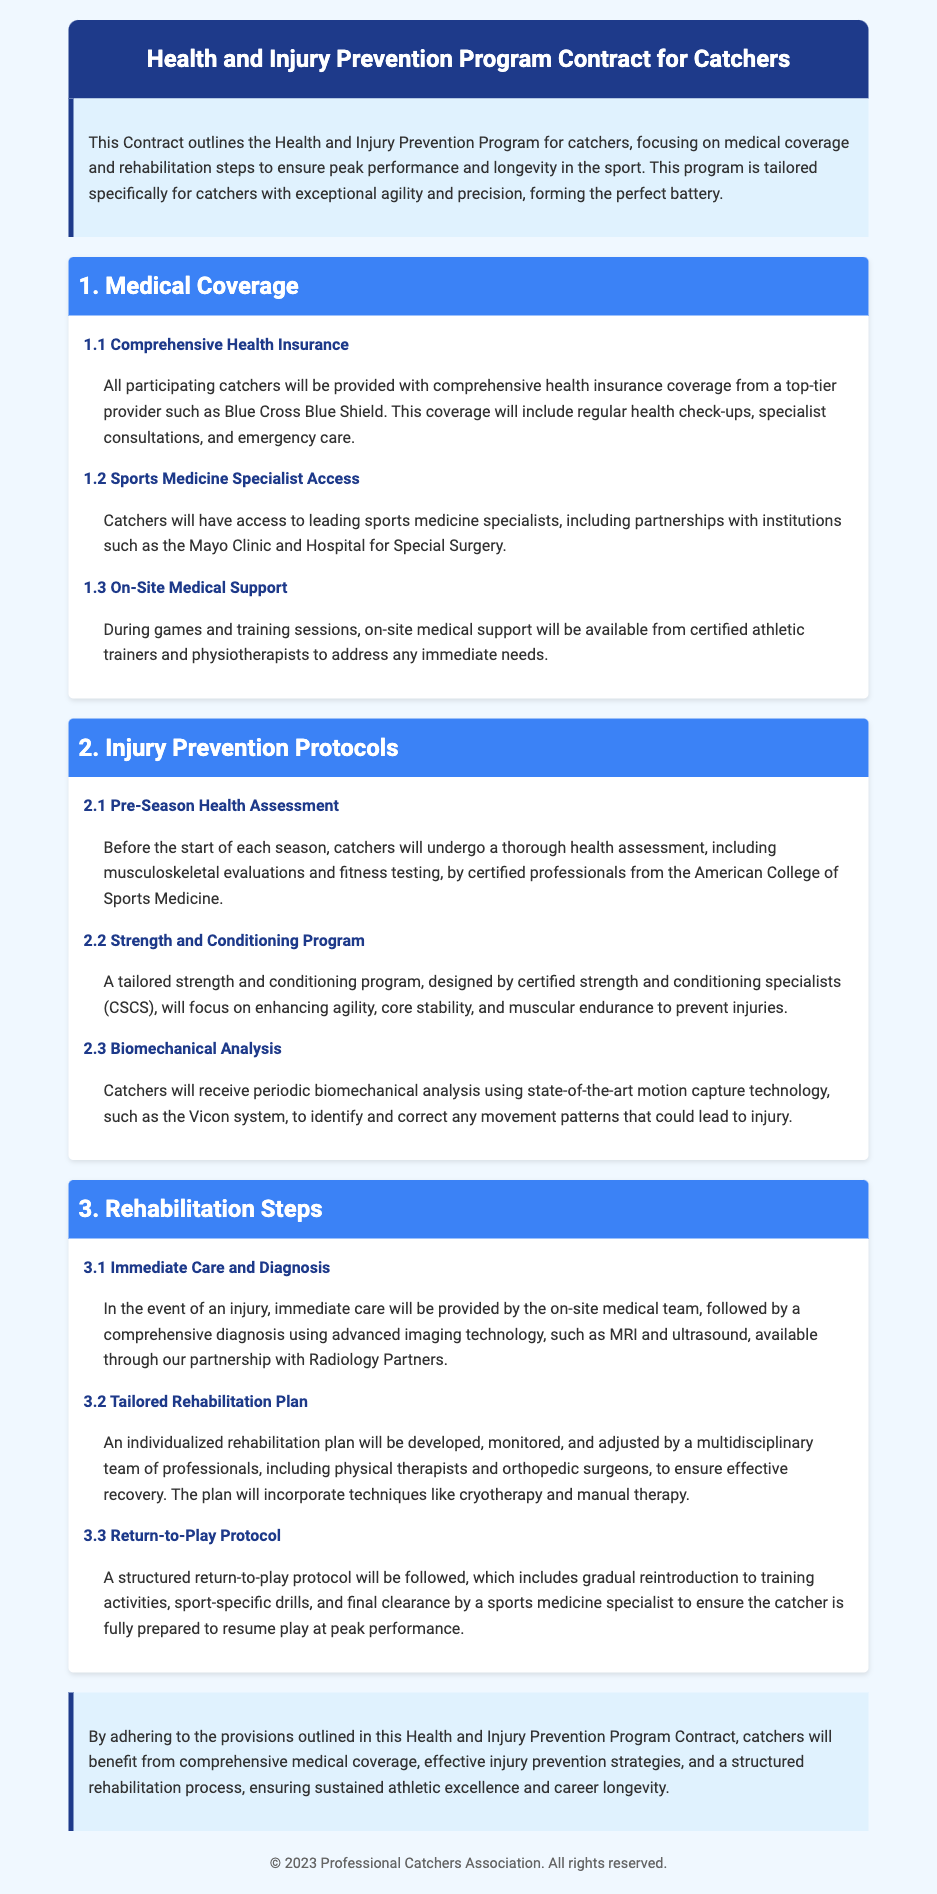What is the purpose of the contract? The contract outlines medical coverage and rehabilitation steps to ensure peak performance and longevity in the sport for catchers.
Answer: Health and Injury Prevention Program Who provides the comprehensive health insurance? The document states that the insurance is provided by a top-tier provider.
Answer: Blue Cross Blue Shield What type of specialists will catchers have access to? The document mentions that catchers will have access to leading specialists for specific needs.
Answer: Sports medicine specialists What is included in the pre-season health assessment? The assessment includes specific evaluations to check the players' health status before the season starts.
Answer: Musculoskeletal evaluations and fitness testing What technology is used for biomechanical analysis? The document specifies the type of technology used for analyzing movement to prevent injuries.
Answer: Vicon system What is the first step taken in case of an injury? The document outlines the immediate action required when an injury occurs.
Answer: Immediate care by the on-site medical team Who monitors the rehabilitation plan? The text details who is responsible for overseeing the rehabilitation plan's effectiveness.
Answer: Multidisciplinary team of professionals What is necessary for a return-to-play clearance? The document states a particular professional is required for final approval to resume play.
Answer: Sports medicine specialist 